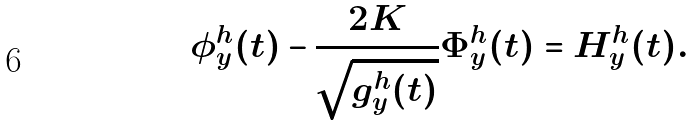<formula> <loc_0><loc_0><loc_500><loc_500>\phi ^ { h } _ { y } ( t ) - \frac { 2 K } { \sqrt { g ^ { h } _ { y } ( t ) } } \Phi ^ { h } _ { y } ( t ) = H ^ { h } _ { y } ( t ) .</formula> 